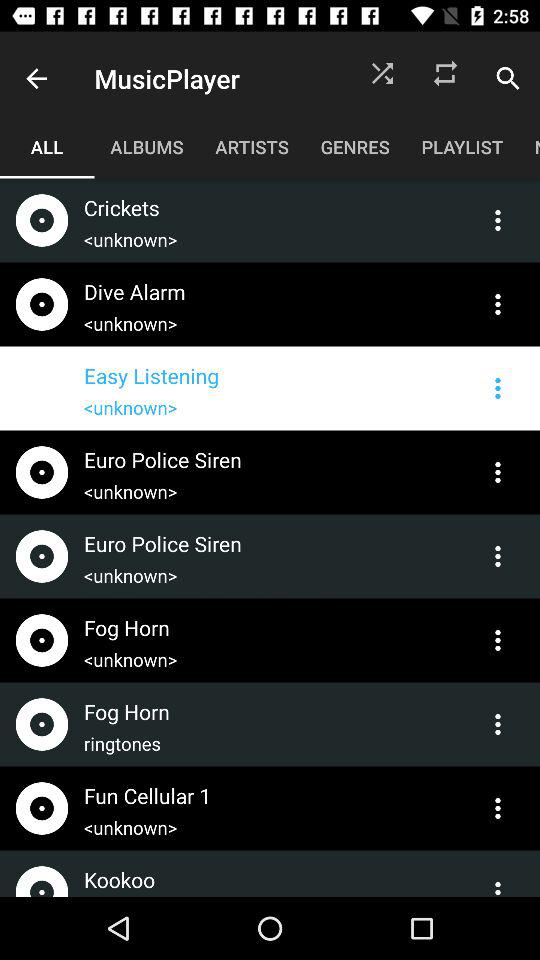Which tab am I on? You are on the "ALL" tab. 